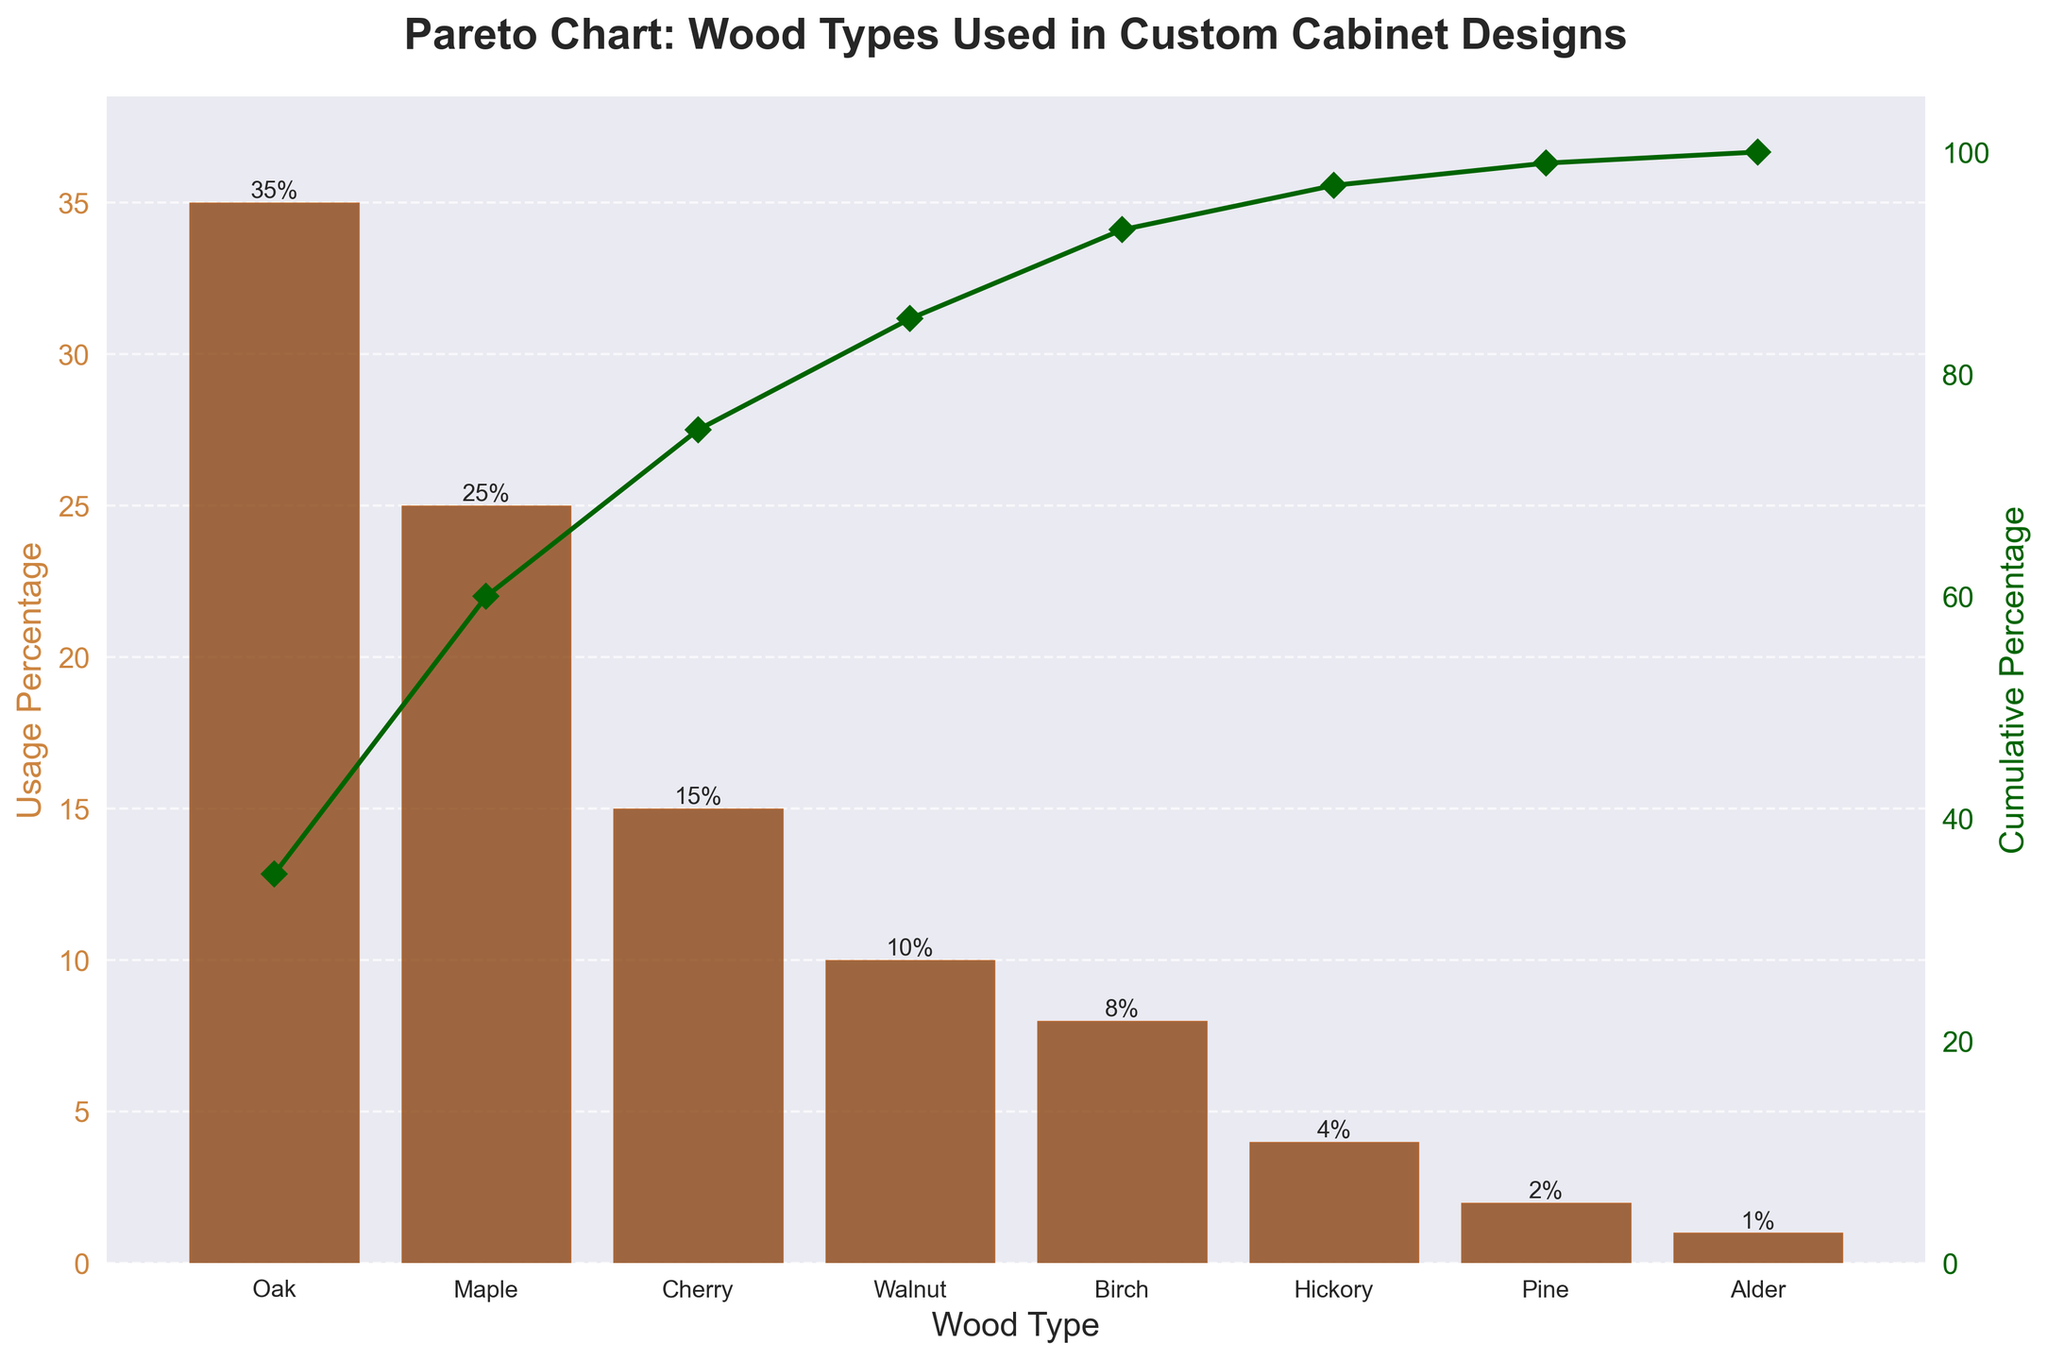what is the most used wood type for custom cabinet designs? The chart shows the usage percentage of different wood types. Oak is at the top of the chart with 35% usage.
Answer: Oak How many wood types are shown in the bar chart? By counting the bars in the chart, we find there are 8 different wood types displayed.
Answer: 8 What is the title of the chart? The title is located at the top of the figure and reads "Pareto Chart: Wood Types Used in Custom Cabinet Designs".
Answer: Pareto Chart: Wood Types Used in Custom Cabinet Designs Which wood type has the lowest usage percentage? The bar chart shows that Alder has the smallest bar with a usage percentage of 1%.
Answer: Alder What is the usage percentage of Cherry wood? By looking at the bar corresponding to Cherry, the label on top of the bar indicates a usage percentage of 15%.
Answer: 15% What is the cumulative percentage for Walnut? From the cumulative line plot, we observe that the value for Walnut (10%) aligns with a cumulative percentage of around 85%.
Answer: 85% How much more popular is Oak compared to Pine in custom cabinet designs? Oak has a usage percentage of 35%, while Pine has 2%. Thus, Oak is 35% - 2% = 33% more popular than Pine.
Answer: 33% What is the combined usage percentage of Birch and Hickory? Birch has 8% and Hickory has 4%. Adding these together, 8% + 4% = 12%.
Answer: 12% What wood types together account for approximately 50% of the usage in cabinet designs? Oak alone accounts for 35%, and when combined with Maple at 25%, they account for 60%. Therefore, Oak and Maple together exceed 50%.
Answer: Oak, Maple How does the cumulative percentage change from Birch to Hickory? The cumulative percentage for Birch is around 93%, and for Hickory, it is around 97%. The change in cumulative percentage is 97% - 93% = 4%.
Answer: 4% 